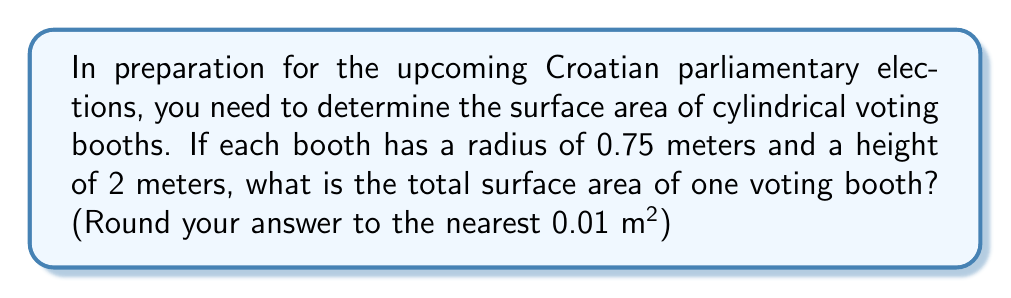Help me with this question. To find the surface area of a cylindrical voting booth, we need to calculate the area of the circular top and bottom, plus the area of the curved side surface.

1. Area of the circular top and bottom:
   $A_{circle} = \pi r^2$
   $A_{circle} = \pi (0.75 \text{ m})^2 = 1.7671... \text{ m}^2$
   There are two circular surfaces, so: $2 \times 1.7671... = 3.5342... \text{ m}^2$

2. Area of the curved side surface:
   $A_{side} = 2\pi r h$
   $A_{side} = 2\pi (0.75 \text{ m})(2 \text{ m}) = 9.4247... \text{ m}^2$

3. Total surface area:
   $A_{total} = 2\pi r^2 + 2\pi r h$
   $A_{total} = 3.5342... \text{ m}^2 + 9.4247... \text{ m}^2 = 12.9590... \text{ m}^2$

4. Rounding to the nearest 0.01 m²:
   $A_{total} \approx 12.96 \text{ m}^2$

[asy]
import geometry;

size(200);
real r = 0.75;
real h = 2;

path p = (0,0)--(0,h)--(r,h)--(r,0)--cycle;
revolution cyl = revolution(p,Z);
draw(cyl,lightgray);
draw(shift(0,0,h)*circle((0,0),r));
draw((r,0,0)--(r,0,h),dashed);
draw((0,0,0)--(r,0,0),Arrow);
label("$r$",(r/2,0,0),S);
draw((r,0,0)--(r,h,0),Arrow);
label("$h$",(r,h/2,0),E);
[/asy]
Answer: $12.96 \text{ m}^2$ 